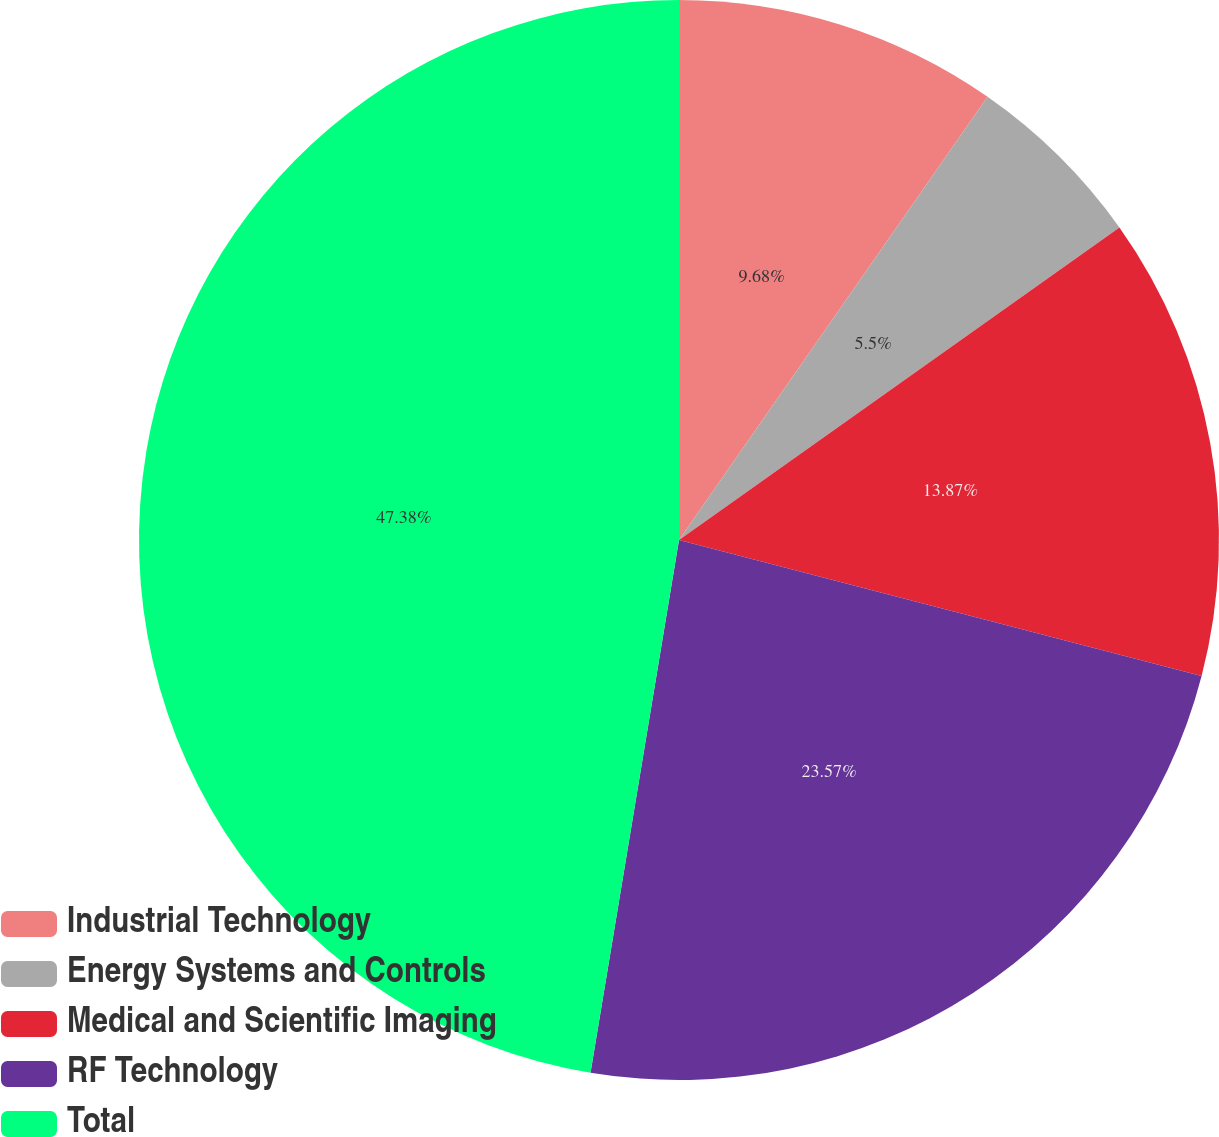<chart> <loc_0><loc_0><loc_500><loc_500><pie_chart><fcel>Industrial Technology<fcel>Energy Systems and Controls<fcel>Medical and Scientific Imaging<fcel>RF Technology<fcel>Total<nl><fcel>9.68%<fcel>5.5%<fcel>13.87%<fcel>23.57%<fcel>47.38%<nl></chart> 